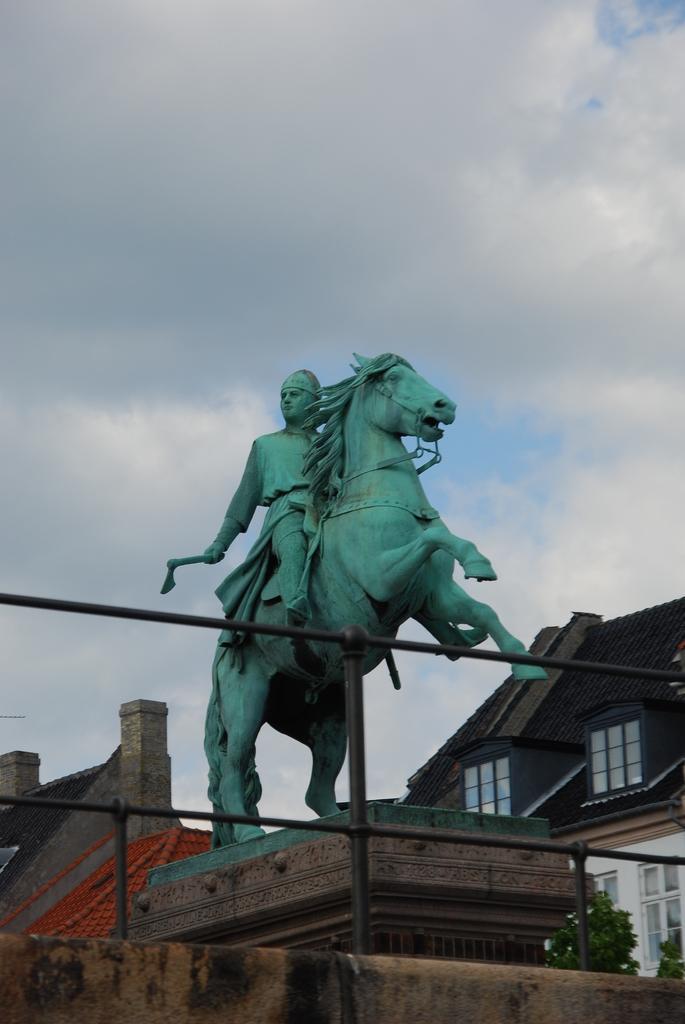Please provide a concise description of this image. In the center of the image we can see a statue. We can also see some houses with roof and windows, trees, a fence and the sky which looks cloudy. 